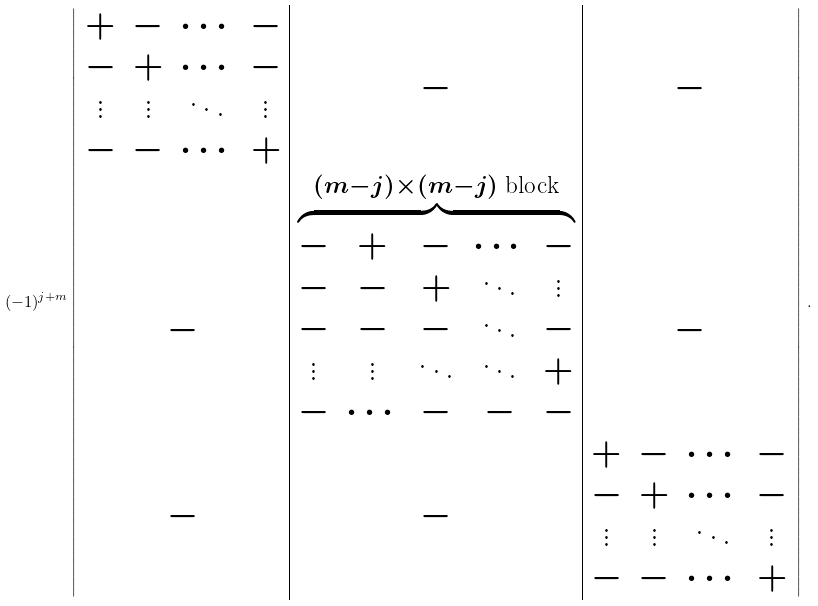Convert formula to latex. <formula><loc_0><loc_0><loc_500><loc_500>( - 1 ) ^ { j + m } \left | \begin{array} { c | c | c } \begin{matrix} + & - & \cdots & - \\ - & + & \cdots & - \\ \vdots & \vdots & \ddots & \vdots \\ - & - & \cdots & + \end{matrix} & - & - \\ - & \overbrace { \begin{matrix} - & + & - & \cdots & - \\ - & - & + & \ddots & \vdots \\ - & - & - & \ddots & - \\ \vdots & \vdots & \ddots & \ddots & + \\ - & \cdots & - & - & - \end{matrix} } ^ { ( m - j ) \times ( m - j ) \text { block} } & - \\ - & - & \begin{matrix} + & - & \cdots & - \\ - & + & \cdots & - \\ \vdots & \vdots & \ddots & \vdots \\ - & - & \cdots & + \end{matrix} \end{array} \right | \, .</formula> 